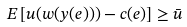<formula> <loc_0><loc_0><loc_500><loc_500>E \left [ u ( w ( y ( e ) ) ) - c ( e ) \right ] \geq { \bar { u } }</formula> 